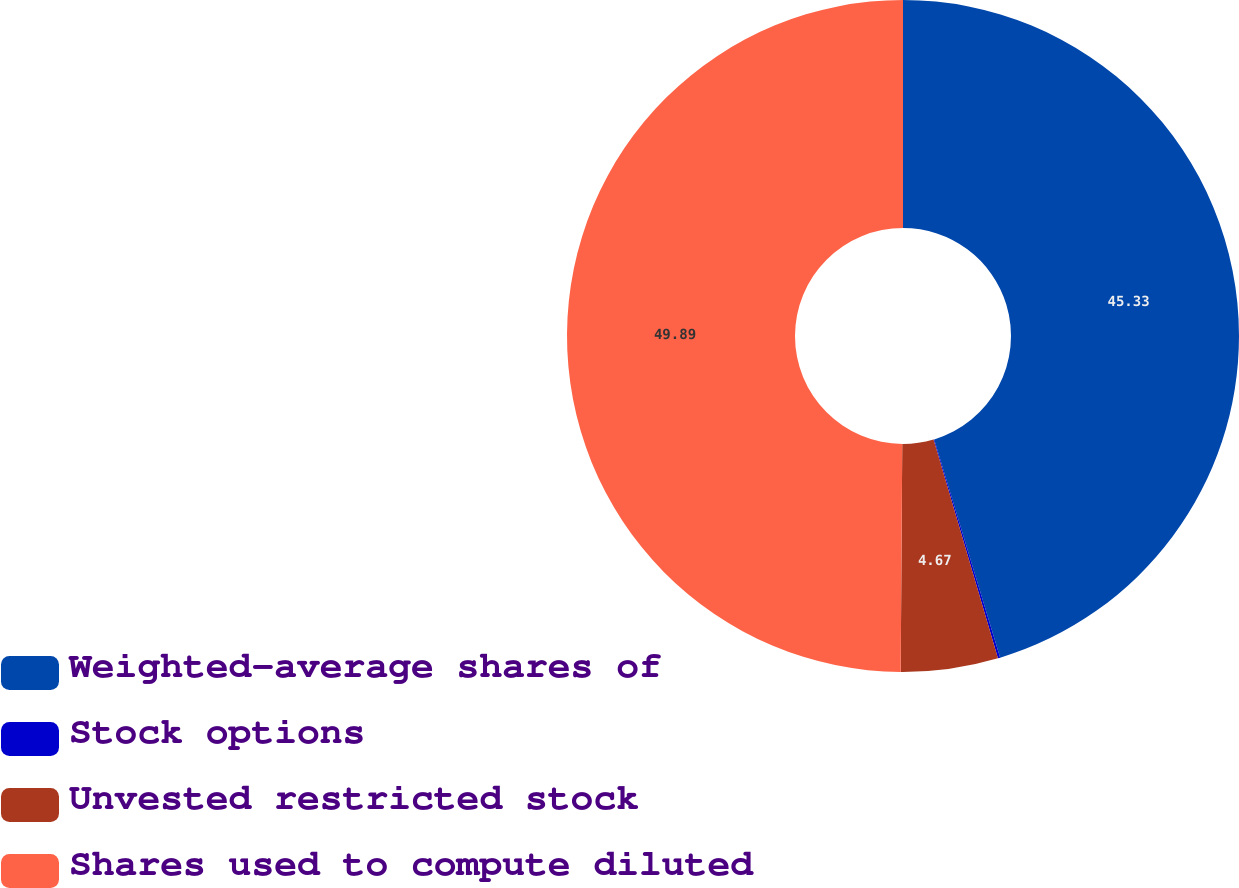Convert chart to OTSL. <chart><loc_0><loc_0><loc_500><loc_500><pie_chart><fcel>Weighted-average shares of<fcel>Stock options<fcel>Unvested restricted stock<fcel>Shares used to compute diluted<nl><fcel>45.33%<fcel>0.11%<fcel>4.67%<fcel>49.89%<nl></chart> 